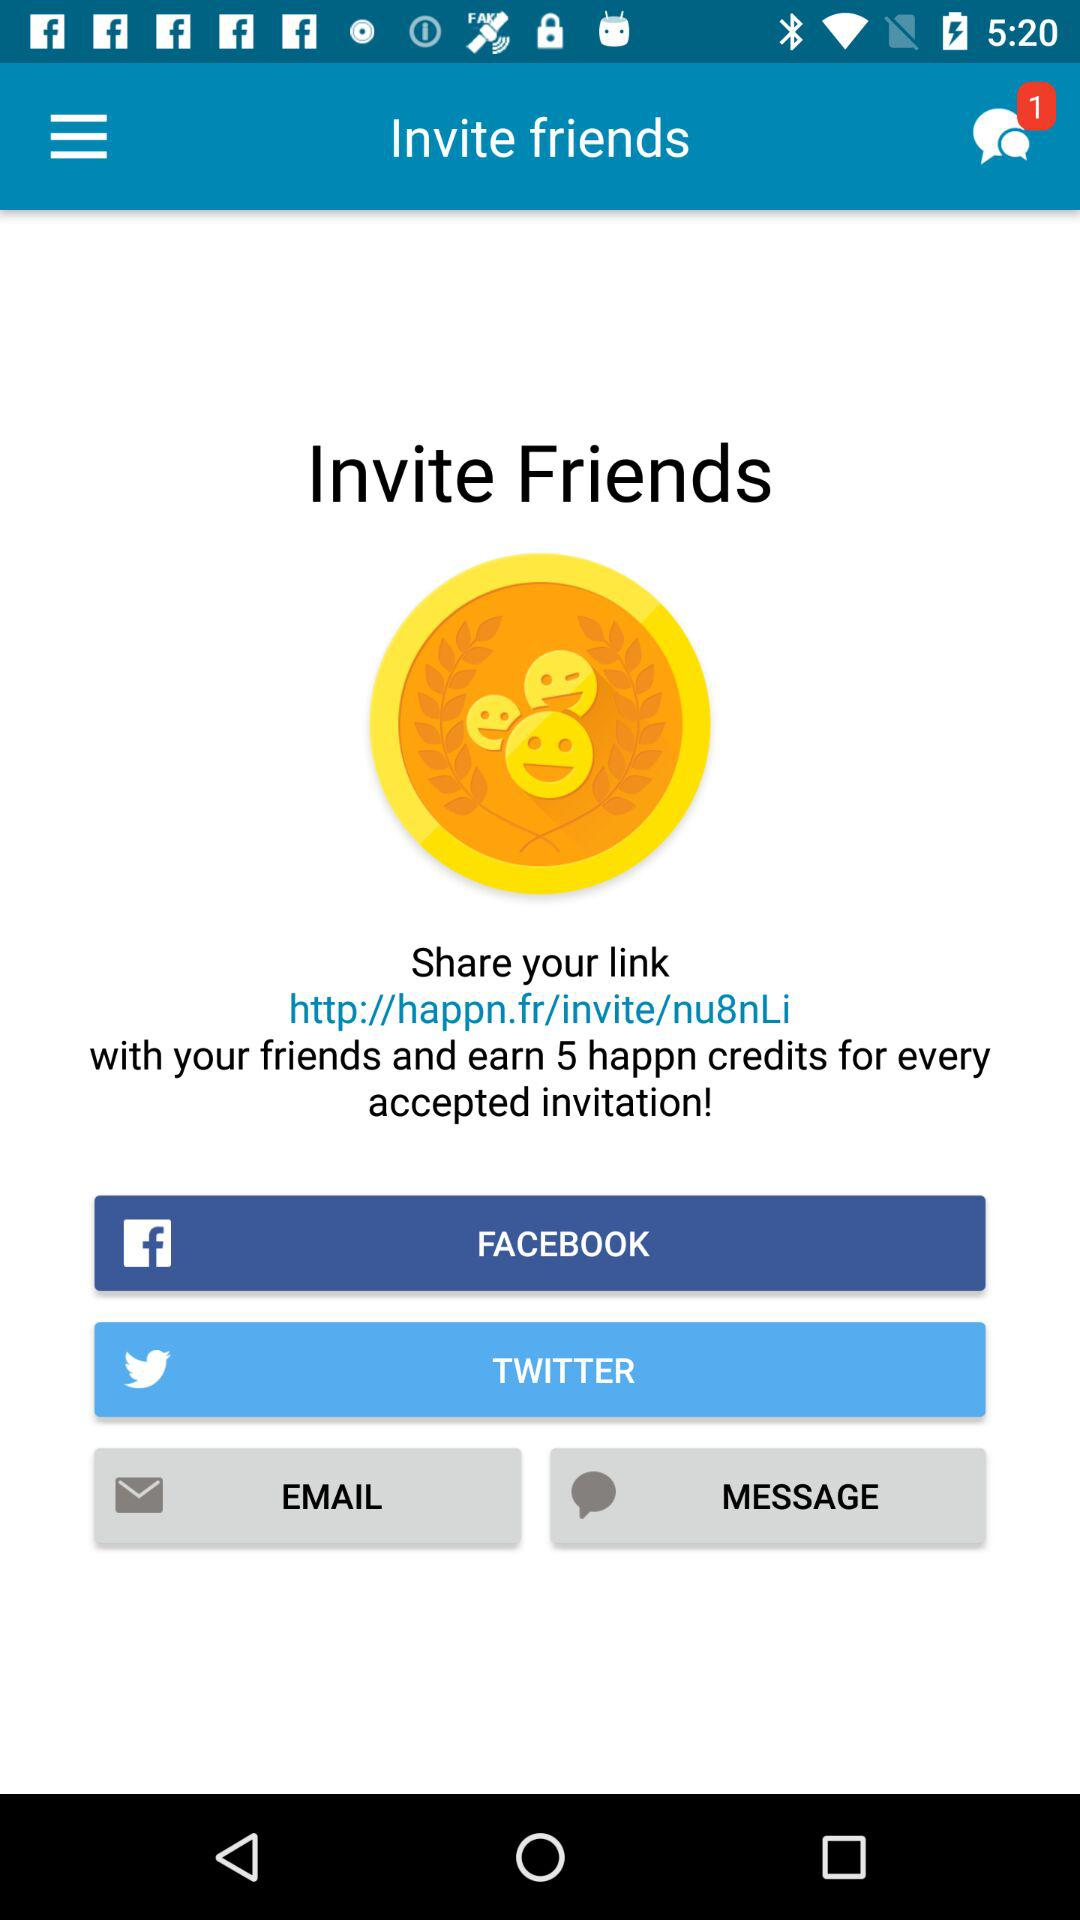How many "happn" credits will I earn for each accepted invitation? You will earn 5 "happn" credits for each accepted invitation. 